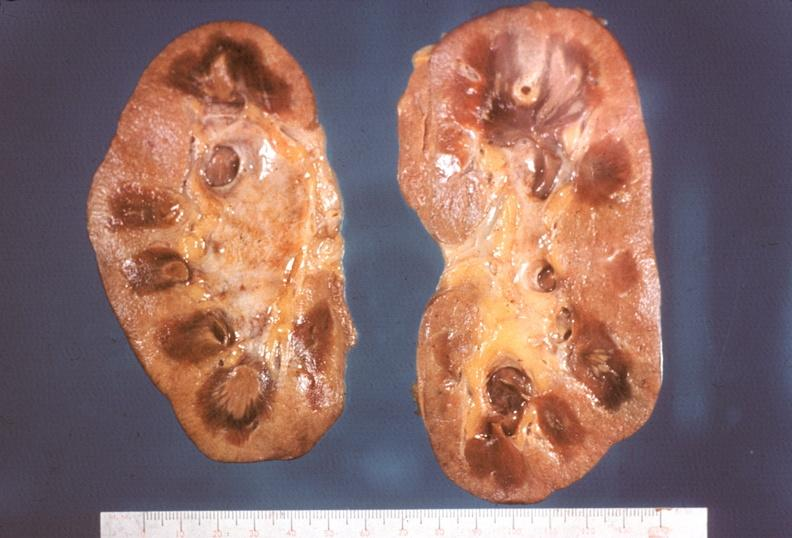s chronic lymphocytic leukemia necrotizing?
Answer the question using a single word or phrase. No 